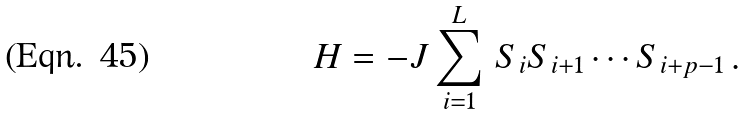Convert formula to latex. <formula><loc_0><loc_0><loc_500><loc_500>H = - J \sum _ { i = 1 } ^ { L } \, S _ { i } S _ { i + 1 } \cdots S _ { i + p - 1 } \, .</formula> 